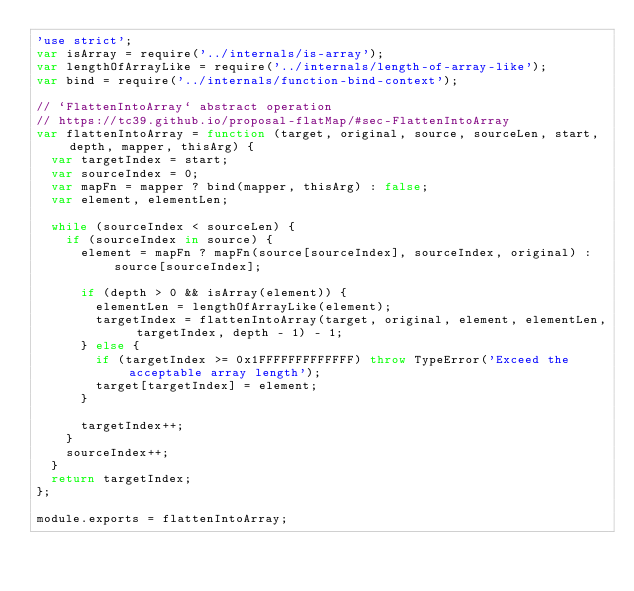<code> <loc_0><loc_0><loc_500><loc_500><_JavaScript_>'use strict';
var isArray = require('../internals/is-array');
var lengthOfArrayLike = require('../internals/length-of-array-like');
var bind = require('../internals/function-bind-context');

// `FlattenIntoArray` abstract operation
// https://tc39.github.io/proposal-flatMap/#sec-FlattenIntoArray
var flattenIntoArray = function (target, original, source, sourceLen, start, depth, mapper, thisArg) {
  var targetIndex = start;
  var sourceIndex = 0;
  var mapFn = mapper ? bind(mapper, thisArg) : false;
  var element, elementLen;

  while (sourceIndex < sourceLen) {
    if (sourceIndex in source) {
      element = mapFn ? mapFn(source[sourceIndex], sourceIndex, original) : source[sourceIndex];

      if (depth > 0 && isArray(element)) {
        elementLen = lengthOfArrayLike(element);
        targetIndex = flattenIntoArray(target, original, element, elementLen, targetIndex, depth - 1) - 1;
      } else {
        if (targetIndex >= 0x1FFFFFFFFFFFFF) throw TypeError('Exceed the acceptable array length');
        target[targetIndex] = element;
      }

      targetIndex++;
    }
    sourceIndex++;
  }
  return targetIndex;
};

module.exports = flattenIntoArray;
</code> 